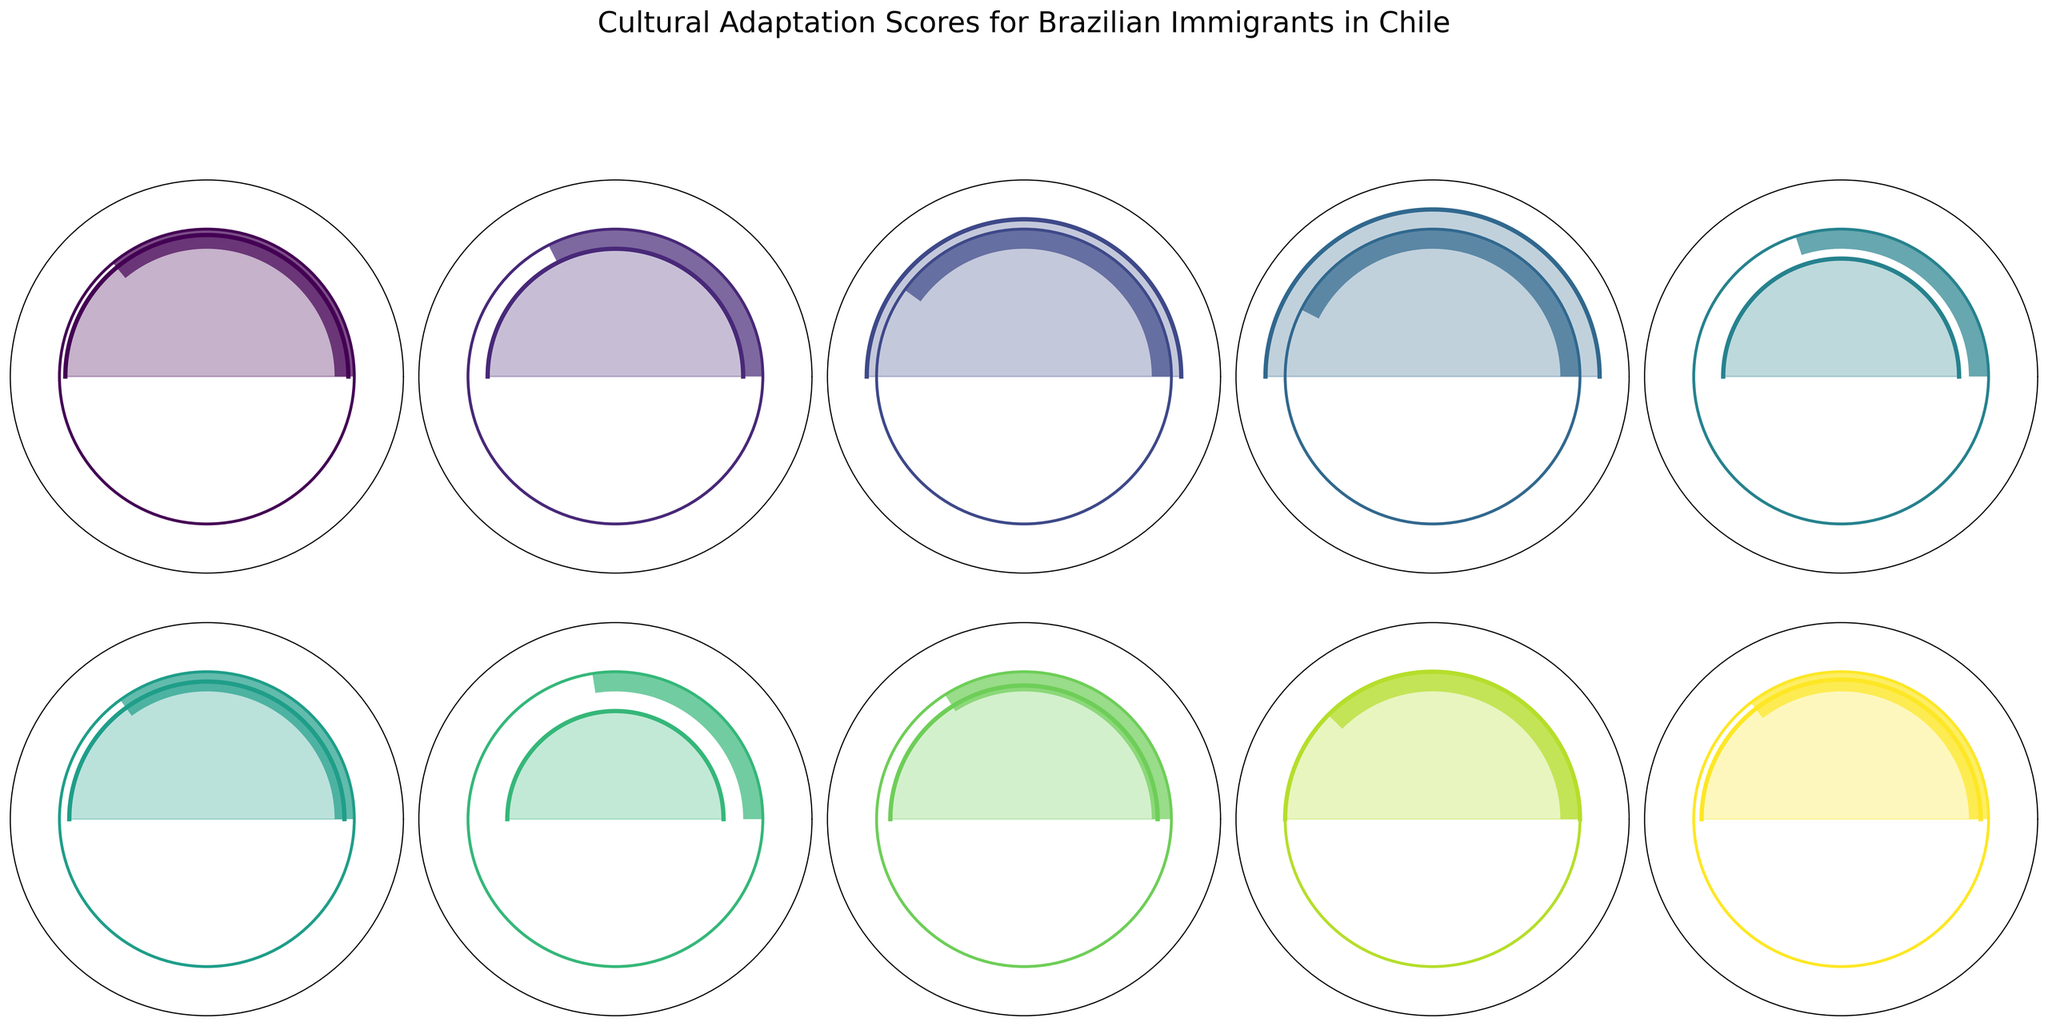What's the title of the figure? The title is displayed at the top of the figure and summarizes what the figure is about.
Answer: Cultural Adaptation Scores for Brazilian Immigrants in Chile What are the scores for Language Proficiency and Food Habits Adaptation? The figure shows each cultural aspect along with its associated adaptation score. Look for Language Proficiency and Food Habits Adaptation, and note down their scores.
Answer: 72 and 85 Which cultural aspect has the lowest adaptation score? Identify the wedge/bar with the smallest length or the aspect with the smallest number on the plot.
Answer: Healthcare System Navigation What is the difference in adaptation scores between Work Environment Adjustment and Climate Acclimation? Find the scores for both Work Environment Adjustment and Climate Acclimation, then calculate the difference by subtracting the smaller score from the larger.
Answer: 20 How many cultural aspects have an adaptation score of 70 or higher? Count the number of wedges or bars that extend to a score of 70 or higher.
Answer: 7 Which cultural aspect has the highest degree wedge/color fill? Look for the wedge that spans the largest angle or has the greatest extent. Check the aspect name it represents.
Answer: Food Habits Adaptation What is the average adaptation score across all the cultural aspects? Sum all the adaptation scores and divide by the number of cultural aspects.
Answer: 70.1 Is Social Integration rated higher or lower than Overall Cultural Adaptation? Compare the adaptation scores of Social Integration and Overall Cultural Adaptation.
Answer: Lower What adaptation score is represented by the color at the exact center of the color gradient used in the figure? Find the midpoint of the color gradient and identify the adaptation score associated with this color. Since colors are likely coded linearly, the midpoint score is at 50% of the gradient. Typically each wedge would reflect this grading visually.
Answer: Around 70 (Approximate) Which aspect would require the most improvement based on the adaptation scores? Identify the aspect with the lowest adaptation score, indicating it has the most room for improvement.
Answer: Healthcare System Navigation 